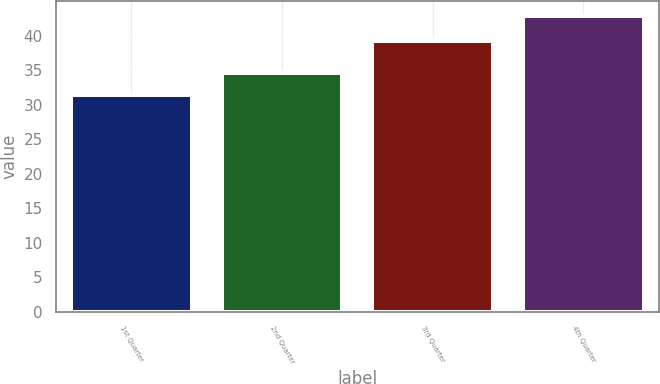<chart> <loc_0><loc_0><loc_500><loc_500><bar_chart><fcel>1st Quarter<fcel>2nd Quarter<fcel>3rd Quarter<fcel>4th Quarter<nl><fcel>31.41<fcel>34.58<fcel>39.2<fcel>42.82<nl></chart> 